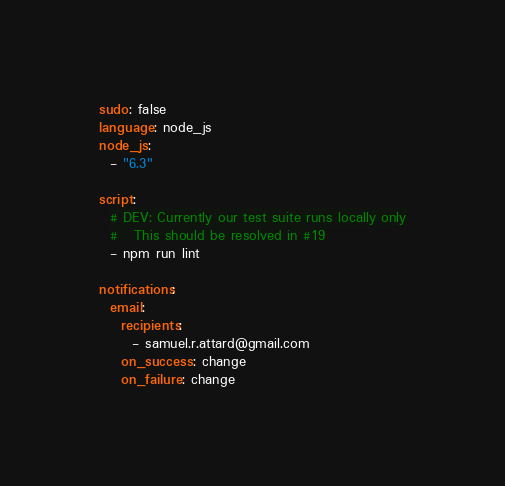<code> <loc_0><loc_0><loc_500><loc_500><_YAML_>sudo: false
language: node_js
node_js:
  - "6.3"

script:
  # DEV: Currently our test suite runs locally only
  #   This should be resolved in #19
  - npm run lint

notifications:
  email:
    recipients:
      - samuel.r.attard@gmail.com
    on_success: change
    on_failure: change
</code> 